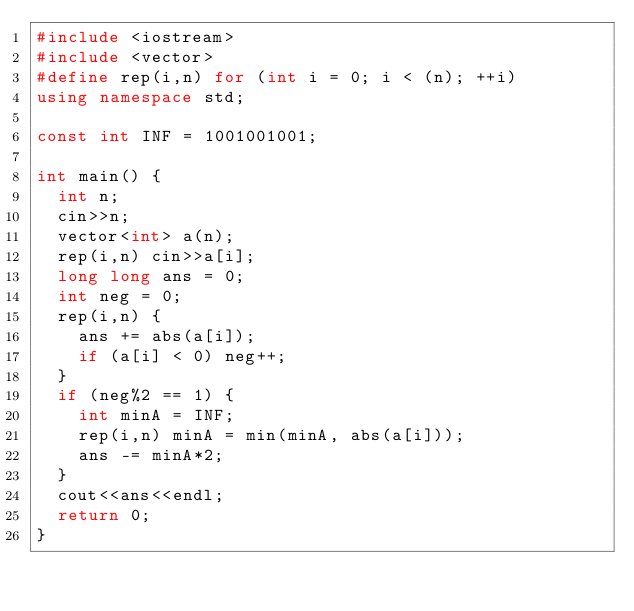<code> <loc_0><loc_0><loc_500><loc_500><_C++_>#include <iostream>
#include <vector>
#define rep(i,n) for (int i = 0; i < (n); ++i)
using namespace std;

const int INF = 1001001001;

int main() {
  int n;
  cin>>n;
  vector<int> a(n);
  rep(i,n) cin>>a[i];
  long long ans = 0;
  int neg = 0;
  rep(i,n) {
    ans += abs(a[i]);
    if (a[i] < 0) neg++;
  }
  if (neg%2 == 1) {
    int minA = INF;
    rep(i,n) minA = min(minA, abs(a[i]));
    ans -= minA*2;
  }
  cout<<ans<<endl;
  return 0;
}</code> 